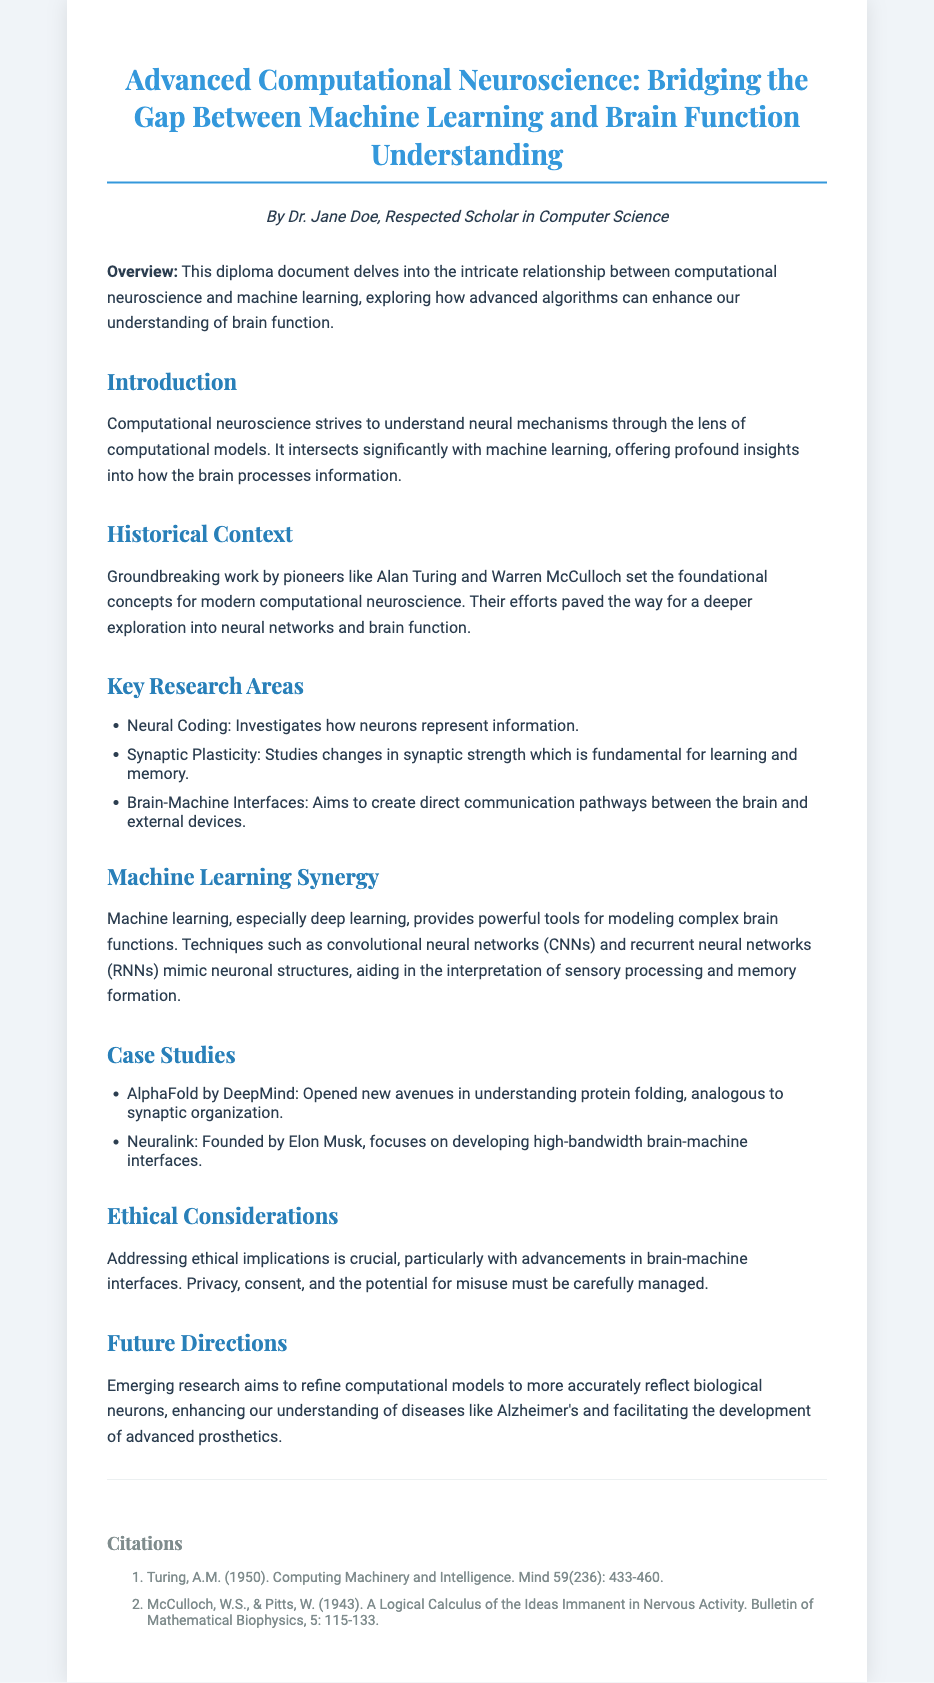What is the title of the diploma? The title of the diploma is prominently featured at the top of the document and reads "Advanced Computational Neuroscience: Bridging the Gap Between Machine Learning and Brain Function Understanding."
Answer: Advanced Computational Neuroscience: Bridging the Gap Between Machine Learning and Brain Function Understanding Who is the author of the diploma? The author is indicated below the title, identified as "Dr. Jane Doe, Respected Scholar in Computer Science."
Answer: Dr. Jane Doe What is a key research area mentioned in the document? The document lists various research areas under the "Key Research Areas" section, including "Neural Coding."
Answer: Neural Coding What significant work did Alan Turing contribute to? The document states that Alan Turing's foundational concepts paved the way for various explorations in the field, particularly mentioning "Computing Machinery and Intelligence."
Answer: Computing Machinery and Intelligence Which machine learning technique is said to mimic neuronal structures? The document describes specific techniques employed in machine learning, explicitly highlighting "convolutional neural networks (CNNs)."
Answer: convolutional neural networks (CNNs) What is a future direction mentioned in the diploma? The diploma touches on prospective research focusing on accurate computational models of biological neurons to help understand diseases and develop prosthetics, particularly mentioning "advanced prosthetics."
Answer: advanced prosthetics What ethical implications are highlighted in the document? Within the "Ethical Considerations" section, the document emphasizes the necessity to address concerns related to "privacy."
Answer: privacy Which company focuses on high-bandwidth brain-machine interfaces? The document mentions a company founded by Elon Musk that specializes in developing brain-machine interfaces, specifically identified as "Neuralink."
Answer: Neuralink What publication year is associated with McCulloch and Pitts' work? The document cites McCulloch and Pitts' work in the year stated as "1943."
Answer: 1943 